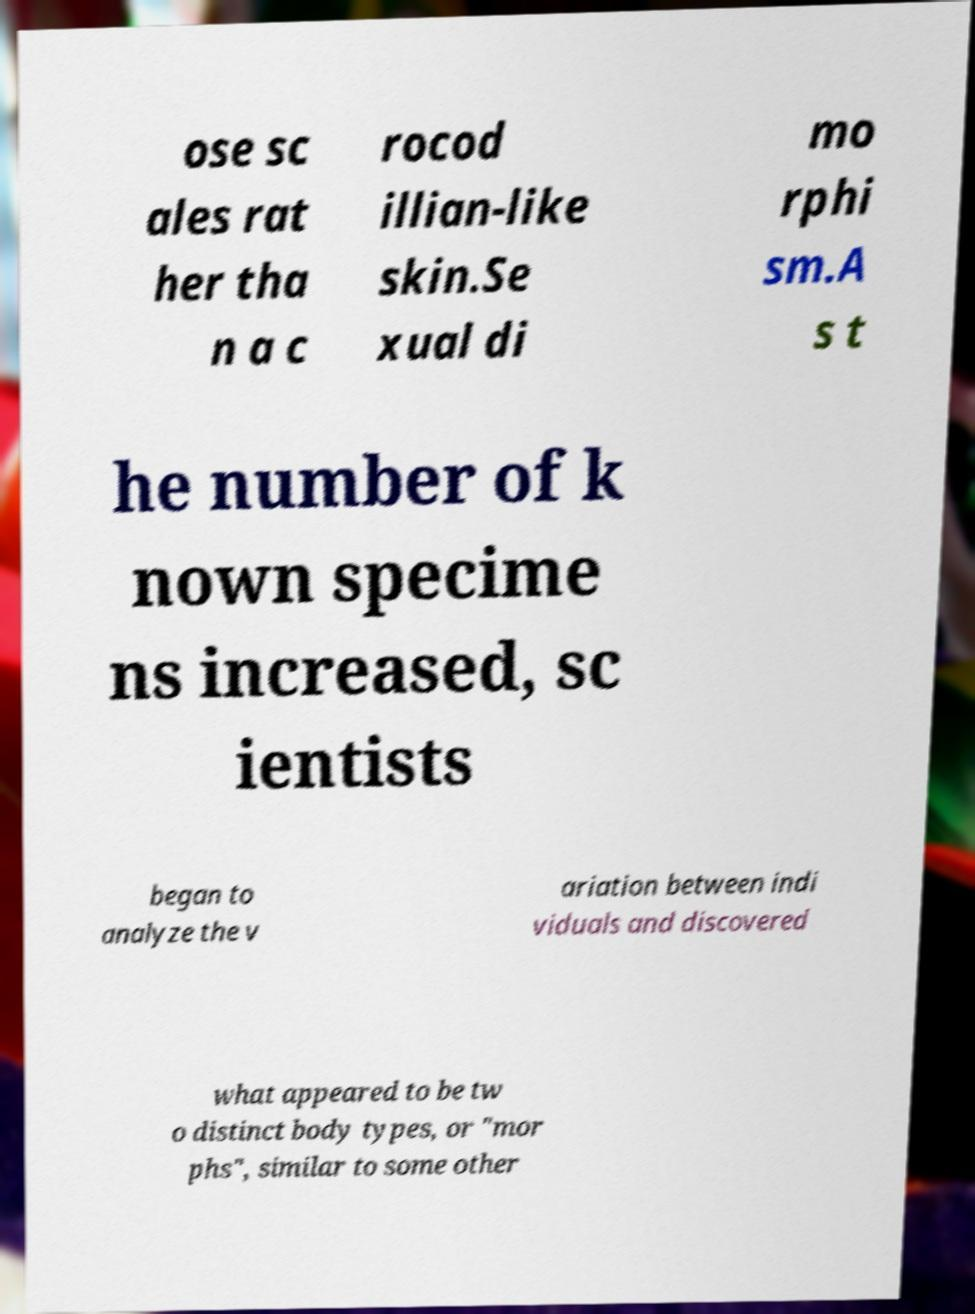Can you read and provide the text displayed in the image?This photo seems to have some interesting text. Can you extract and type it out for me? ose sc ales rat her tha n a c rocod illian-like skin.Se xual di mo rphi sm.A s t he number of k nown specime ns increased, sc ientists began to analyze the v ariation between indi viduals and discovered what appeared to be tw o distinct body types, or "mor phs", similar to some other 